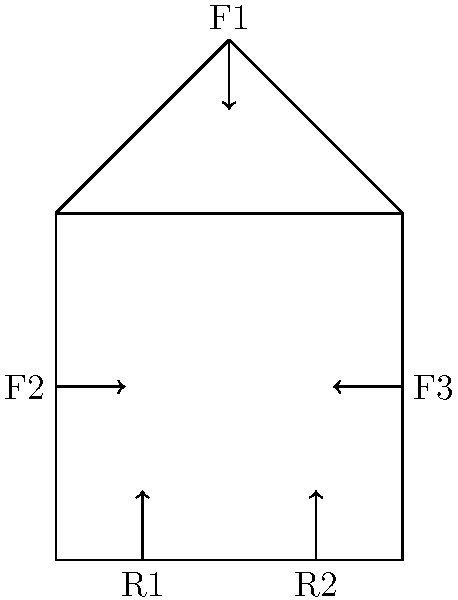In the structural design of a monastic prayer hall, a simplified load-bearing diagram is shown above. If the vertical force F1 is 10 kN, and the horizontal forces F2 and F3 are each 5 kN, what is the magnitude of the reaction force R1 assuming the structure is in equilibrium? To solve this problem, we'll use the principles of static equilibrium. For a structure to be in equilibrium, the sum of all forces and moments must be zero.

Step 1: Identify the known forces
F1 = 10 kN (downward)
F2 = 5 kN (rightward)
F3 = 5 kN (leftward)

Step 2: Set up the equilibrium equations
For vertical equilibrium: $$\sum F_y = 0$$
$$-F1 + R1 + R2 = 0$$

For horizontal equilibrium: $$\sum F_x = 0$$
$$F2 - F3 = 0$$ (This is already satisfied as F2 = F3)

For moment equilibrium (about the left support): $$\sum M = 0$$
$$F1 \cdot 50 - R2 \cdot 100 = 0$$

Step 3: Solve for R2 using the moment equation
$$10 \cdot 50 - R2 \cdot 100 = 0$$
$$500 - 100R2 = 0$$
$$R2 = 5 \text{ kN}$$

Step 4: Solve for R1 using the vertical equilibrium equation
$$-10 + R1 + 5 = 0$$
$$R1 = 5 \text{ kN}$$

Therefore, the magnitude of the reaction force R1 is 5 kN.
Answer: 5 kN 